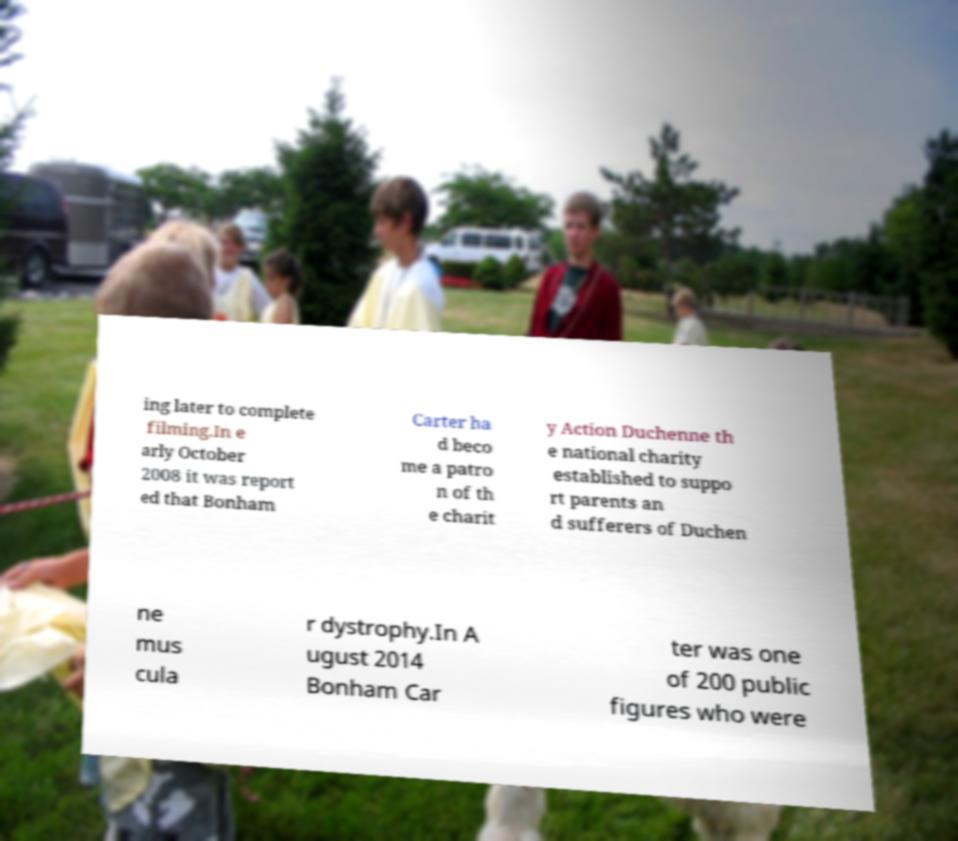Please identify and transcribe the text found in this image. ing later to complete filming.In e arly October 2008 it was report ed that Bonham Carter ha d beco me a patro n of th e charit y Action Duchenne th e national charity established to suppo rt parents an d sufferers of Duchen ne mus cula r dystrophy.In A ugust 2014 Bonham Car ter was one of 200 public figures who were 